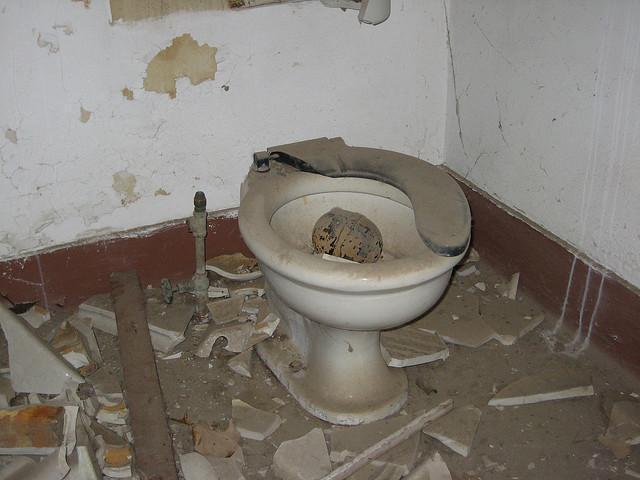How many wheels of this bike are on the ground?
Give a very brief answer. 0. 